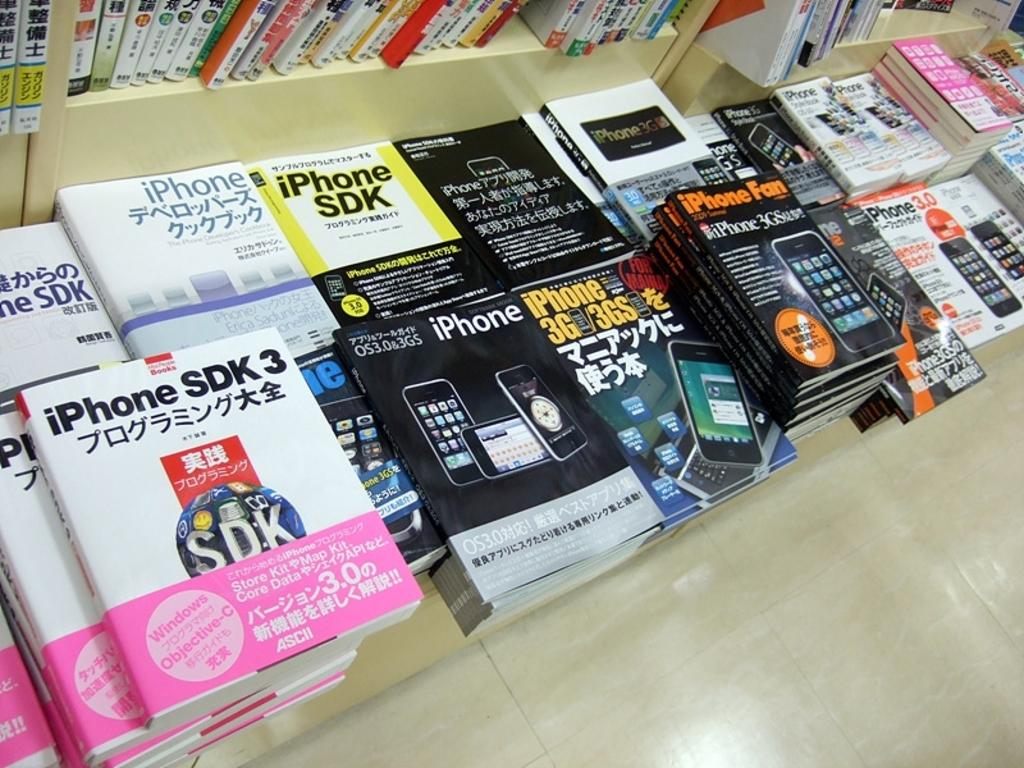<image>
Share a concise interpretation of the image provided. many magazines and phones on the ground including iPHone SDK 3 